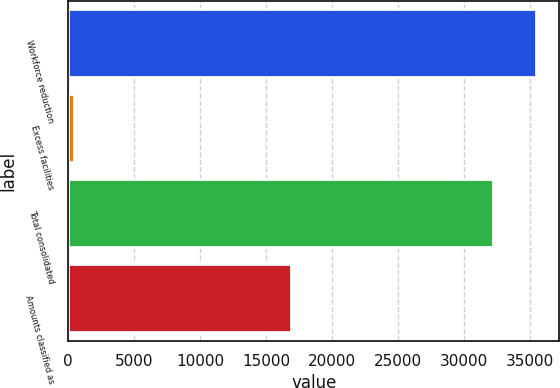<chart> <loc_0><loc_0><loc_500><loc_500><bar_chart><fcel>Workforce reduction<fcel>Excess facilities<fcel>Total consolidated<fcel>Amounts classified as<nl><fcel>35418.9<fcel>424<fcel>32199<fcel>16861<nl></chart> 